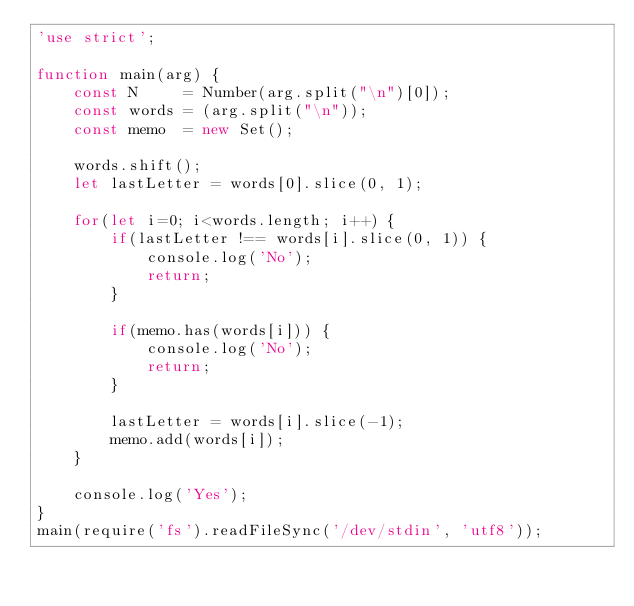Convert code to text. <code><loc_0><loc_0><loc_500><loc_500><_JavaScript_>'use strict';

function main(arg) {
    const N     = Number(arg.split("\n")[0]);
    const words = (arg.split("\n"));
    const memo  = new Set();
    
    words.shift();
    let lastLetter = words[0].slice(0, 1);

    for(let i=0; i<words.length; i++) {
        if(lastLetter !== words[i].slice(0, 1)) {
            console.log('No');
            return;
        }
        
        if(memo.has(words[i])) {
            console.log('No');
            return;
        }

        lastLetter = words[i].slice(-1);
        memo.add(words[i]);
    }
    
    console.log('Yes');
}
main(require('fs').readFileSync('/dev/stdin', 'utf8'));
</code> 